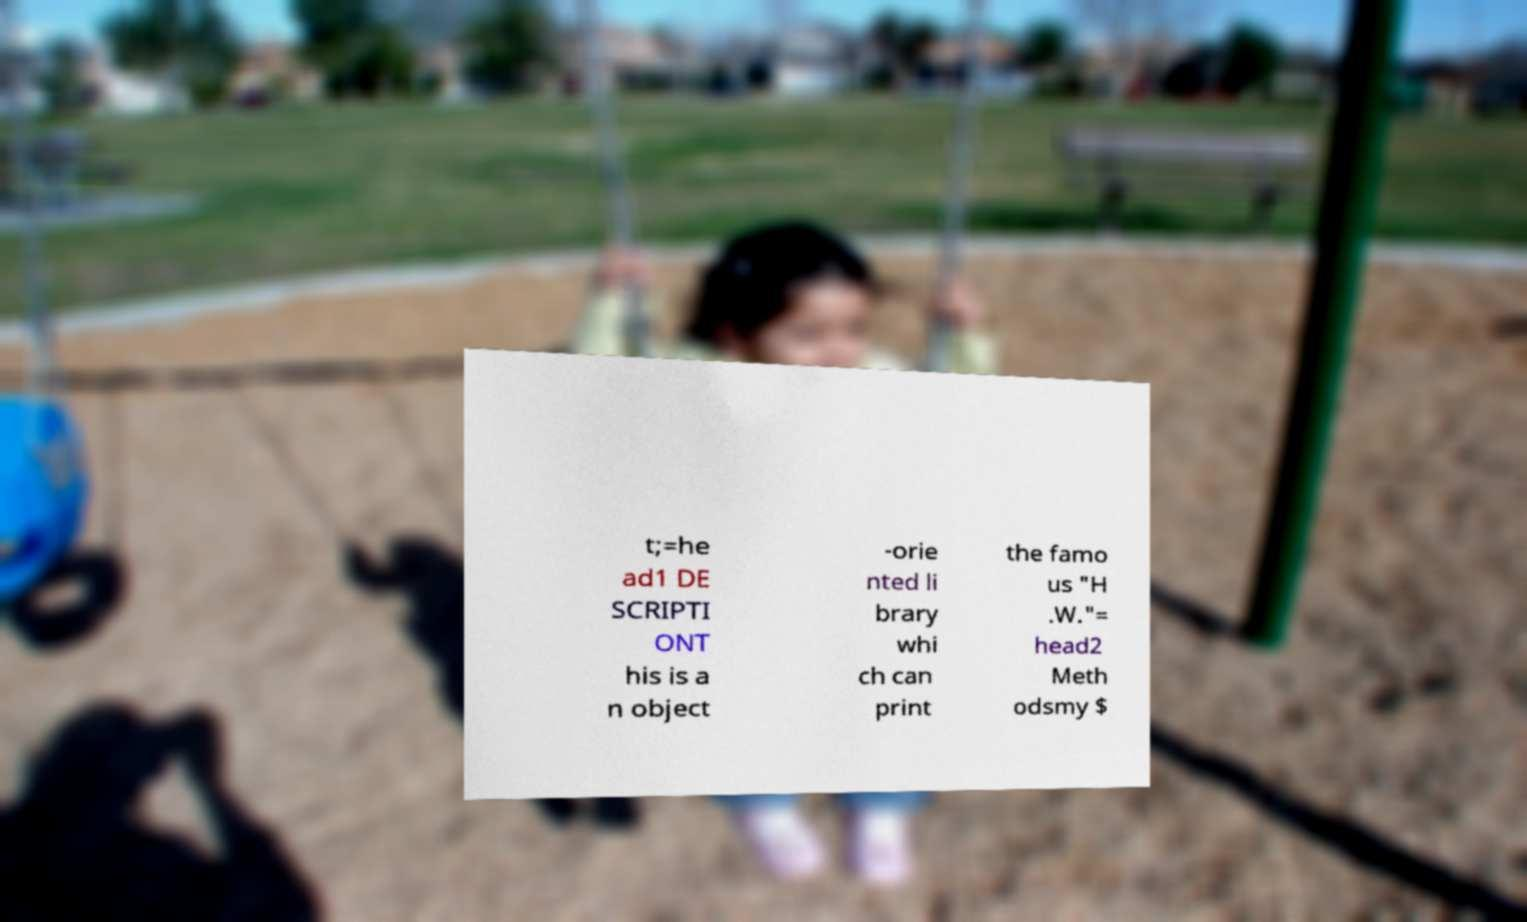Please read and relay the text visible in this image. What does it say? t;=he ad1 DE SCRIPTI ONT his is a n object -orie nted li brary whi ch can print the famo us "H .W."= head2 Meth odsmy $ 